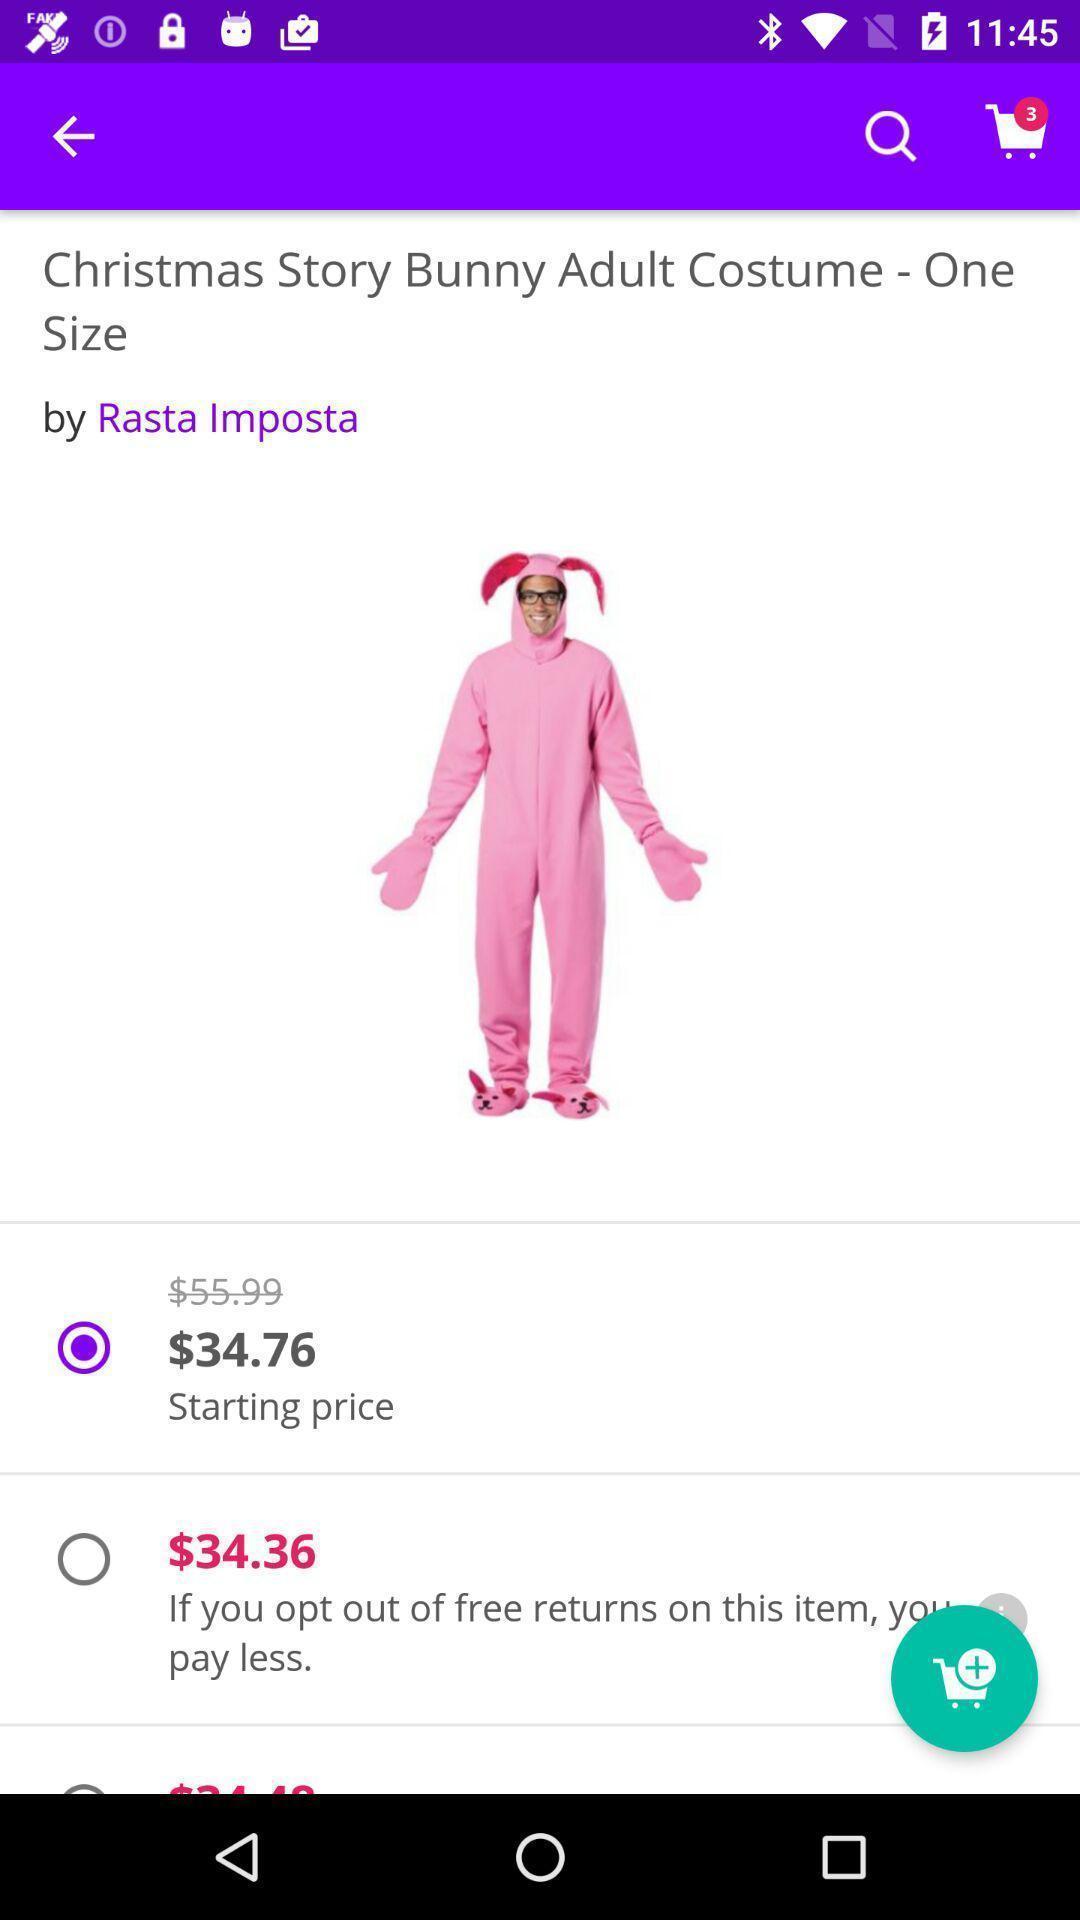Provide a textual representation of this image. Screen shows price of costume in shopping app. 